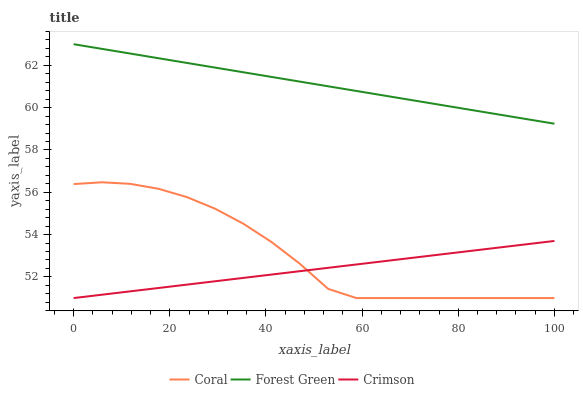Does Crimson have the minimum area under the curve?
Answer yes or no. Yes. Does Forest Green have the maximum area under the curve?
Answer yes or no. Yes. Does Coral have the minimum area under the curve?
Answer yes or no. No. Does Coral have the maximum area under the curve?
Answer yes or no. No. Is Forest Green the smoothest?
Answer yes or no. Yes. Is Coral the roughest?
Answer yes or no. Yes. Is Coral the smoothest?
Answer yes or no. No. Is Forest Green the roughest?
Answer yes or no. No. Does Crimson have the lowest value?
Answer yes or no. Yes. Does Forest Green have the lowest value?
Answer yes or no. No. Does Forest Green have the highest value?
Answer yes or no. Yes. Does Coral have the highest value?
Answer yes or no. No. Is Coral less than Forest Green?
Answer yes or no. Yes. Is Forest Green greater than Crimson?
Answer yes or no. Yes. Does Coral intersect Crimson?
Answer yes or no. Yes. Is Coral less than Crimson?
Answer yes or no. No. Is Coral greater than Crimson?
Answer yes or no. No. Does Coral intersect Forest Green?
Answer yes or no. No. 